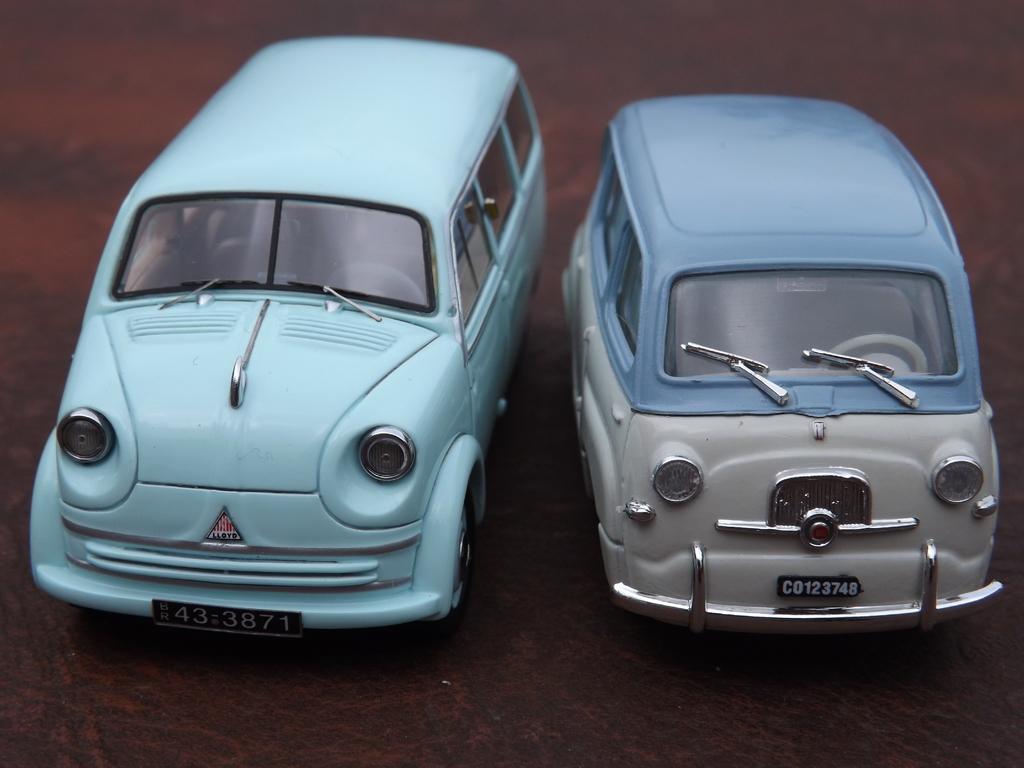How would you summarize this image in a sentence or two? In this image we can see toy cars placed on the surface. 